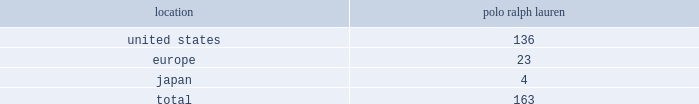In addition to generating sales of our products , our worldwide full-price stores set , reinforce and capitalize on the image of our brands .
Our stores range in size from approximately 800 to over 37500 square feet .
These full- price stores are situated in major upscale street locations and upscale regional malls , generally in large urban markets .
We generally lease our stores for initial periods ranging from 5 to 10 years with renewal options .
We extend our reach to additional consumer groups through our 163 polo ralph lauren factory stores worldwide .
During fiscal 2009 , we added 5 new polo ralph lauren factory stores , net .
Our factory stores are generally located in outlet malls .
We operated the following factory retail stores as of march 28 , 2009 : factory retail stores location ralph lauren .
2022 polo ralph lauren domestic factory stores offer selections of our menswear , womenswear , children 2019s apparel , accessories , home furnishings and fragrances .
Ranging in size from approximately 2700 to 20000 square feet , with an average of approximately 9200 square feet , these stores are principally located in major outlet centers in 36 states and puerto rico .
2022 european factory stores offer selections of our menswear , womenswear , children 2019s apparel , accessories , home furnishings and fragrances .
Ranging in size from approximately 2300 to 10500 square feet , with an average of approximately 6500 square feet , these stores are located in 9 countries , principally in major outlet centers .
2022 japanese factory stores offer selections of our menswear , womenswear , children 2019s apparel , accessories , home furnishings and fragrances .
Ranging in size from approximately 1500 to 12000 square feet , with an average of approximately 7400 square feet , these stores are located in 3 provinces , principally in major outlet centers .
Factory stores obtain products from our suppliers , our product licensing partners and our retail stores .
Ralphlauren.com and rugby.com in addition to our stores , our retail segment sells products online through our e-commerce websites , ralphlauren.com ( http://www.ralphlauren.com ) and rugby.com ( http://www.rugby.com ) .
Ralphlauren.com offers our customers access to the full breadth of ralph lauren apparel , accessories and home products , allows us to reach retail customers on a multi-channel basis and reinforces the luxury image of our brands .
Ralphlauren.com averaged 2.9 million unique visitors a month and acquired approximately 350000 new customers , resulting in 1.7 million total customers in fiscal 2009 .
In august 2008 , the company launched rugby.com , its second e-commerce website .
Rugby.com offers clothing and accessories for purchase 2014 previously only available at rugby stores 2014 along with style tips , unique videos and blog-based content .
Rugby.com offers an extensive array of rugby products for young men and women within a full lifestyle destination .
Our licensing segment through licensing alliances , we combine our consumer insight , design , and marketing skills with the specific product or geographic competencies of our licensing partners to create and build new businesses .
We generally seek out licensing partners who : 2022 are leaders in their respective markets ; 2022 contribute the majority of the product development costs; .
What percentage of factory retail stores as of march 28 , 2009 were located in the united states? 
Computations: (136 / 163)
Answer: 0.83436. 